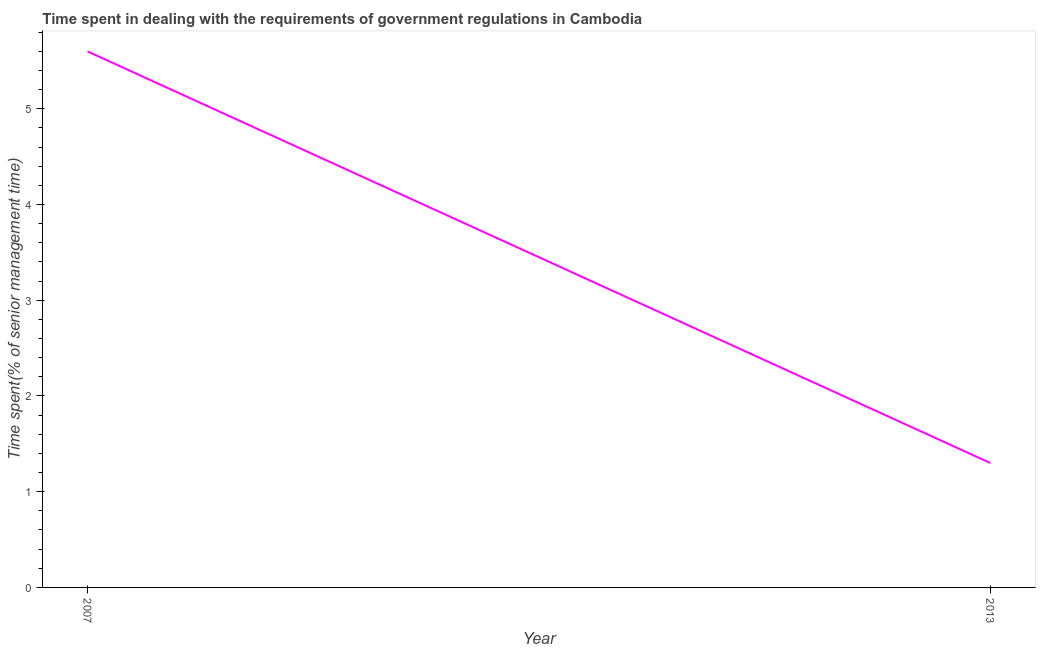What is the time spent in dealing with government regulations in 2007?
Provide a succinct answer. 5.6. Across all years, what is the maximum time spent in dealing with government regulations?
Offer a very short reply. 5.6. Across all years, what is the minimum time spent in dealing with government regulations?
Your answer should be compact. 1.3. In which year was the time spent in dealing with government regulations minimum?
Your response must be concise. 2013. What is the sum of the time spent in dealing with government regulations?
Your answer should be very brief. 6.9. What is the difference between the time spent in dealing with government regulations in 2007 and 2013?
Your answer should be very brief. 4.3. What is the average time spent in dealing with government regulations per year?
Ensure brevity in your answer.  3.45. What is the median time spent in dealing with government regulations?
Provide a short and direct response. 3.45. Do a majority of the years between 2013 and 2007 (inclusive) have time spent in dealing with government regulations greater than 4.6 %?
Make the answer very short. No. What is the ratio of the time spent in dealing with government regulations in 2007 to that in 2013?
Your answer should be compact. 4.31. In how many years, is the time spent in dealing with government regulations greater than the average time spent in dealing with government regulations taken over all years?
Your response must be concise. 1. Are the values on the major ticks of Y-axis written in scientific E-notation?
Your response must be concise. No. Does the graph contain any zero values?
Make the answer very short. No. What is the title of the graph?
Offer a terse response. Time spent in dealing with the requirements of government regulations in Cambodia. What is the label or title of the X-axis?
Provide a short and direct response. Year. What is the label or title of the Y-axis?
Offer a very short reply. Time spent(% of senior management time). What is the Time spent(% of senior management time) in 2007?
Your answer should be compact. 5.6. What is the Time spent(% of senior management time) of 2013?
Offer a very short reply. 1.3. What is the ratio of the Time spent(% of senior management time) in 2007 to that in 2013?
Provide a short and direct response. 4.31. 